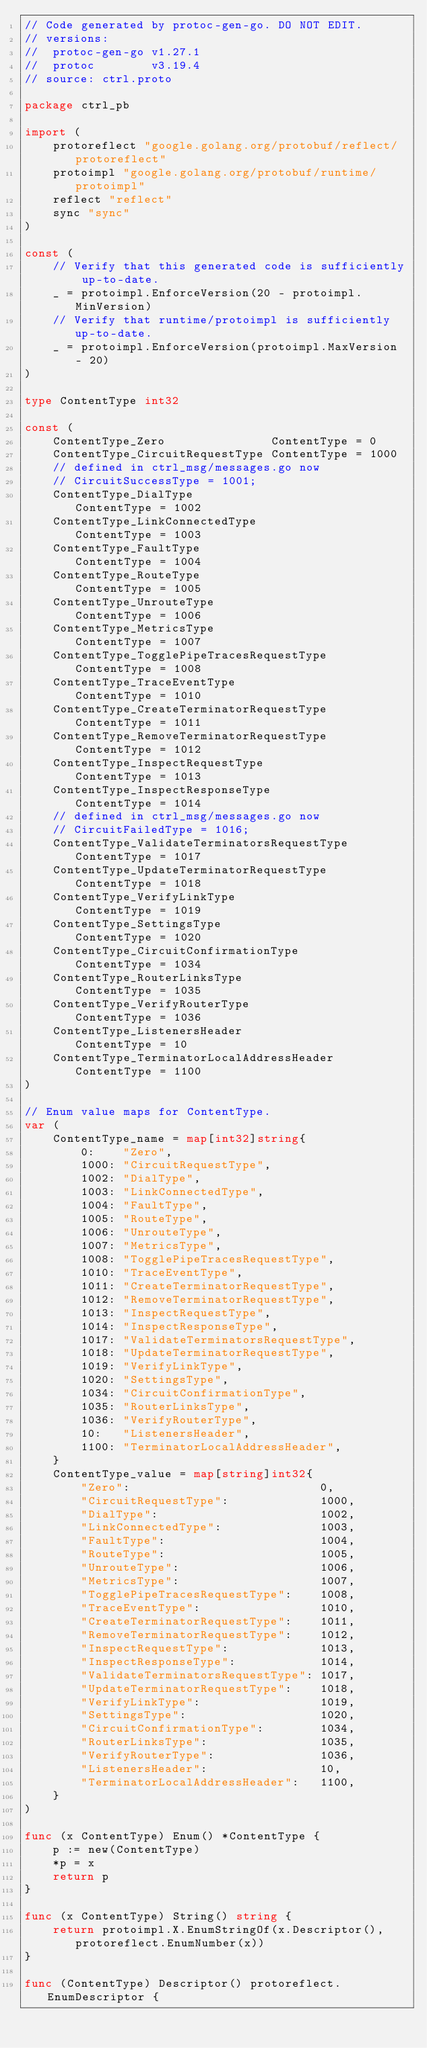<code> <loc_0><loc_0><loc_500><loc_500><_Go_>// Code generated by protoc-gen-go. DO NOT EDIT.
// versions:
// 	protoc-gen-go v1.27.1
// 	protoc        v3.19.4
// source: ctrl.proto

package ctrl_pb

import (
	protoreflect "google.golang.org/protobuf/reflect/protoreflect"
	protoimpl "google.golang.org/protobuf/runtime/protoimpl"
	reflect "reflect"
	sync "sync"
)

const (
	// Verify that this generated code is sufficiently up-to-date.
	_ = protoimpl.EnforceVersion(20 - protoimpl.MinVersion)
	// Verify that runtime/protoimpl is sufficiently up-to-date.
	_ = protoimpl.EnforceVersion(protoimpl.MaxVersion - 20)
)

type ContentType int32

const (
	ContentType_Zero               ContentType = 0
	ContentType_CircuitRequestType ContentType = 1000
	// defined in ctrl_msg/messages.go now
	// CircuitSuccessType = 1001;
	ContentType_DialType                    ContentType = 1002
	ContentType_LinkConnectedType           ContentType = 1003
	ContentType_FaultType                   ContentType = 1004
	ContentType_RouteType                   ContentType = 1005
	ContentType_UnrouteType                 ContentType = 1006
	ContentType_MetricsType                 ContentType = 1007
	ContentType_TogglePipeTracesRequestType ContentType = 1008
	ContentType_TraceEventType              ContentType = 1010
	ContentType_CreateTerminatorRequestType ContentType = 1011
	ContentType_RemoveTerminatorRequestType ContentType = 1012
	ContentType_InspectRequestType          ContentType = 1013
	ContentType_InspectResponseType         ContentType = 1014
	// defined in ctrl_msg/messages.go now
	// CircuitFailedType = 1016;
	ContentType_ValidateTerminatorsRequestType ContentType = 1017
	ContentType_UpdateTerminatorRequestType    ContentType = 1018
	ContentType_VerifyLinkType                 ContentType = 1019
	ContentType_SettingsType                   ContentType = 1020
	ContentType_CircuitConfirmationType        ContentType = 1034
	ContentType_RouterLinksType                ContentType = 1035
	ContentType_VerifyRouterType               ContentType = 1036
	ContentType_ListenersHeader                ContentType = 10
	ContentType_TerminatorLocalAddressHeader   ContentType = 1100
)

// Enum value maps for ContentType.
var (
	ContentType_name = map[int32]string{
		0:    "Zero",
		1000: "CircuitRequestType",
		1002: "DialType",
		1003: "LinkConnectedType",
		1004: "FaultType",
		1005: "RouteType",
		1006: "UnrouteType",
		1007: "MetricsType",
		1008: "TogglePipeTracesRequestType",
		1010: "TraceEventType",
		1011: "CreateTerminatorRequestType",
		1012: "RemoveTerminatorRequestType",
		1013: "InspectRequestType",
		1014: "InspectResponseType",
		1017: "ValidateTerminatorsRequestType",
		1018: "UpdateTerminatorRequestType",
		1019: "VerifyLinkType",
		1020: "SettingsType",
		1034: "CircuitConfirmationType",
		1035: "RouterLinksType",
		1036: "VerifyRouterType",
		10:   "ListenersHeader",
		1100: "TerminatorLocalAddressHeader",
	}
	ContentType_value = map[string]int32{
		"Zero":                           0,
		"CircuitRequestType":             1000,
		"DialType":                       1002,
		"LinkConnectedType":              1003,
		"FaultType":                      1004,
		"RouteType":                      1005,
		"UnrouteType":                    1006,
		"MetricsType":                    1007,
		"TogglePipeTracesRequestType":    1008,
		"TraceEventType":                 1010,
		"CreateTerminatorRequestType":    1011,
		"RemoveTerminatorRequestType":    1012,
		"InspectRequestType":             1013,
		"InspectResponseType":            1014,
		"ValidateTerminatorsRequestType": 1017,
		"UpdateTerminatorRequestType":    1018,
		"VerifyLinkType":                 1019,
		"SettingsType":                   1020,
		"CircuitConfirmationType":        1034,
		"RouterLinksType":                1035,
		"VerifyRouterType":               1036,
		"ListenersHeader":                10,
		"TerminatorLocalAddressHeader":   1100,
	}
)

func (x ContentType) Enum() *ContentType {
	p := new(ContentType)
	*p = x
	return p
}

func (x ContentType) String() string {
	return protoimpl.X.EnumStringOf(x.Descriptor(), protoreflect.EnumNumber(x))
}

func (ContentType) Descriptor() protoreflect.EnumDescriptor {</code> 